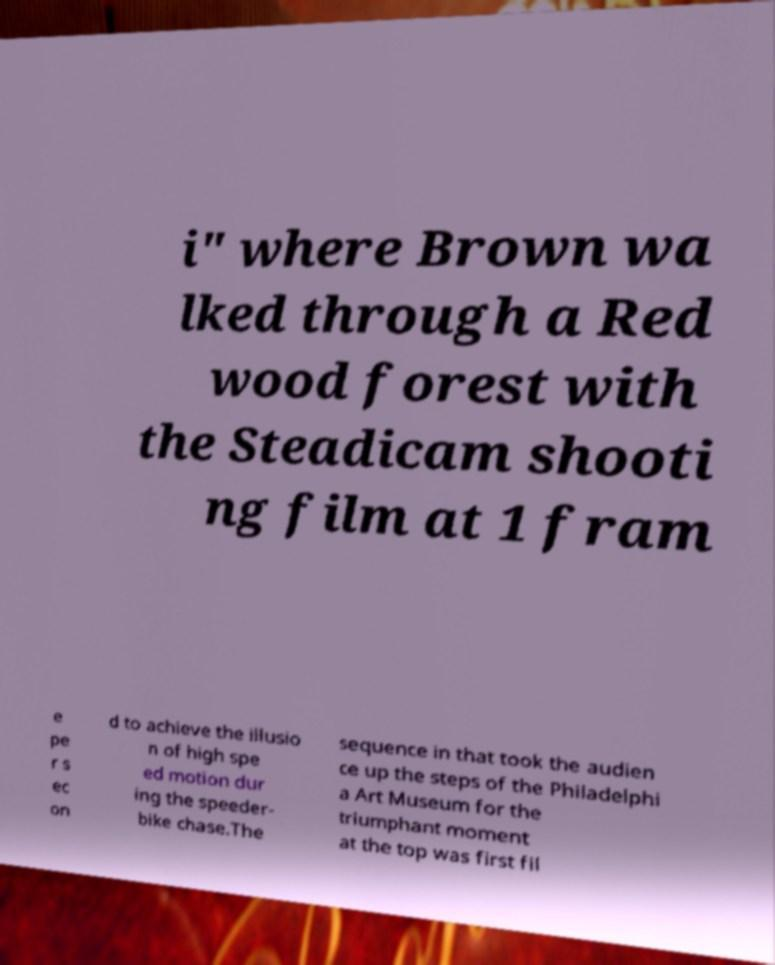What messages or text are displayed in this image? I need them in a readable, typed format. i" where Brown wa lked through a Red wood forest with the Steadicam shooti ng film at 1 fram e pe r s ec on d to achieve the illusio n of high spe ed motion dur ing the speeder- bike chase.The sequence in that took the audien ce up the steps of the Philadelphi a Art Museum for the triumphant moment at the top was first fil 